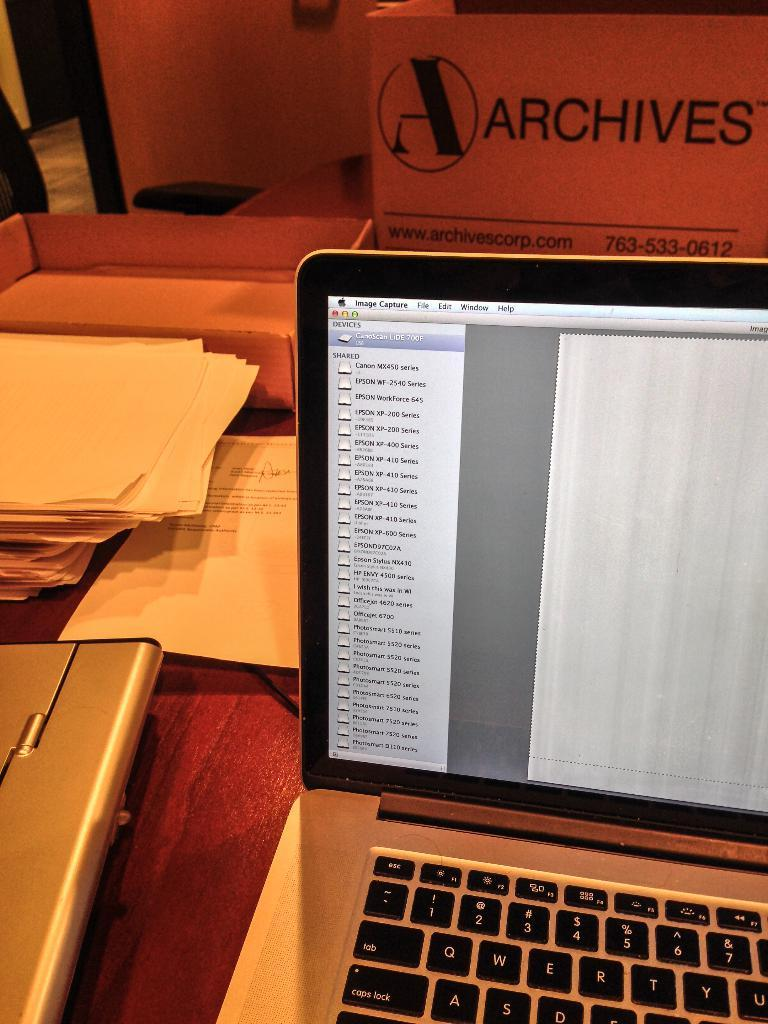<image>
Render a clear and concise summary of the photo. A laptop computer is open and a box that says Archives is in front of it. 